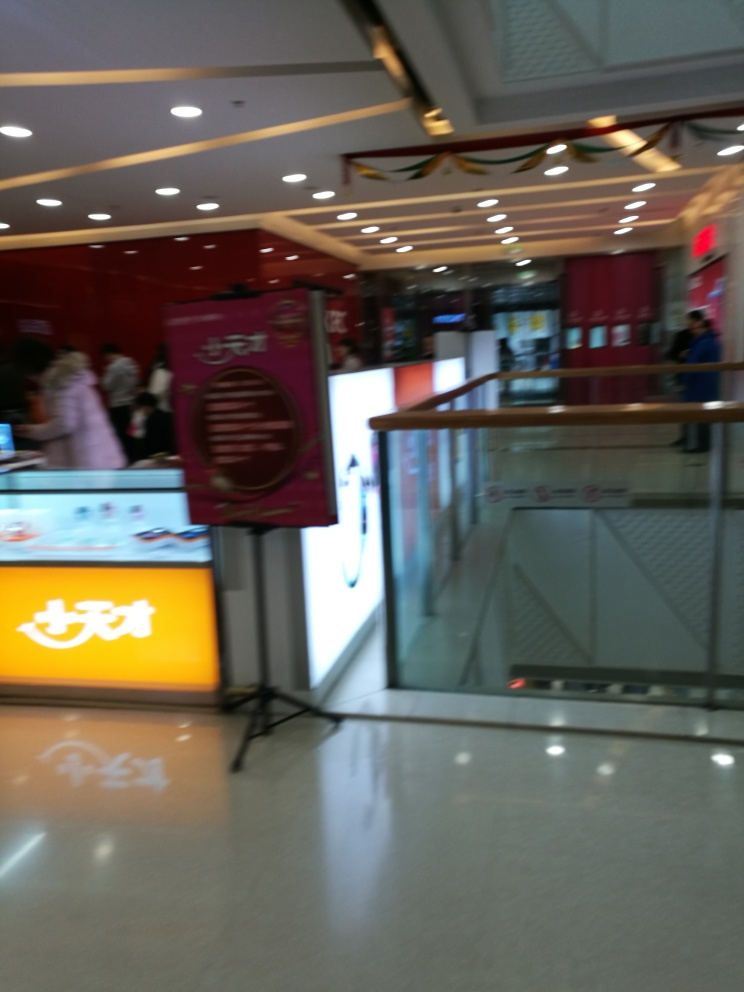Can you tell what kind of place this is? The image seems to be taken inside a shopping mall or commercial building. This is suggested by retail signage, the presence of stores, and the glass barricades that typically line walkways in such complexes. 